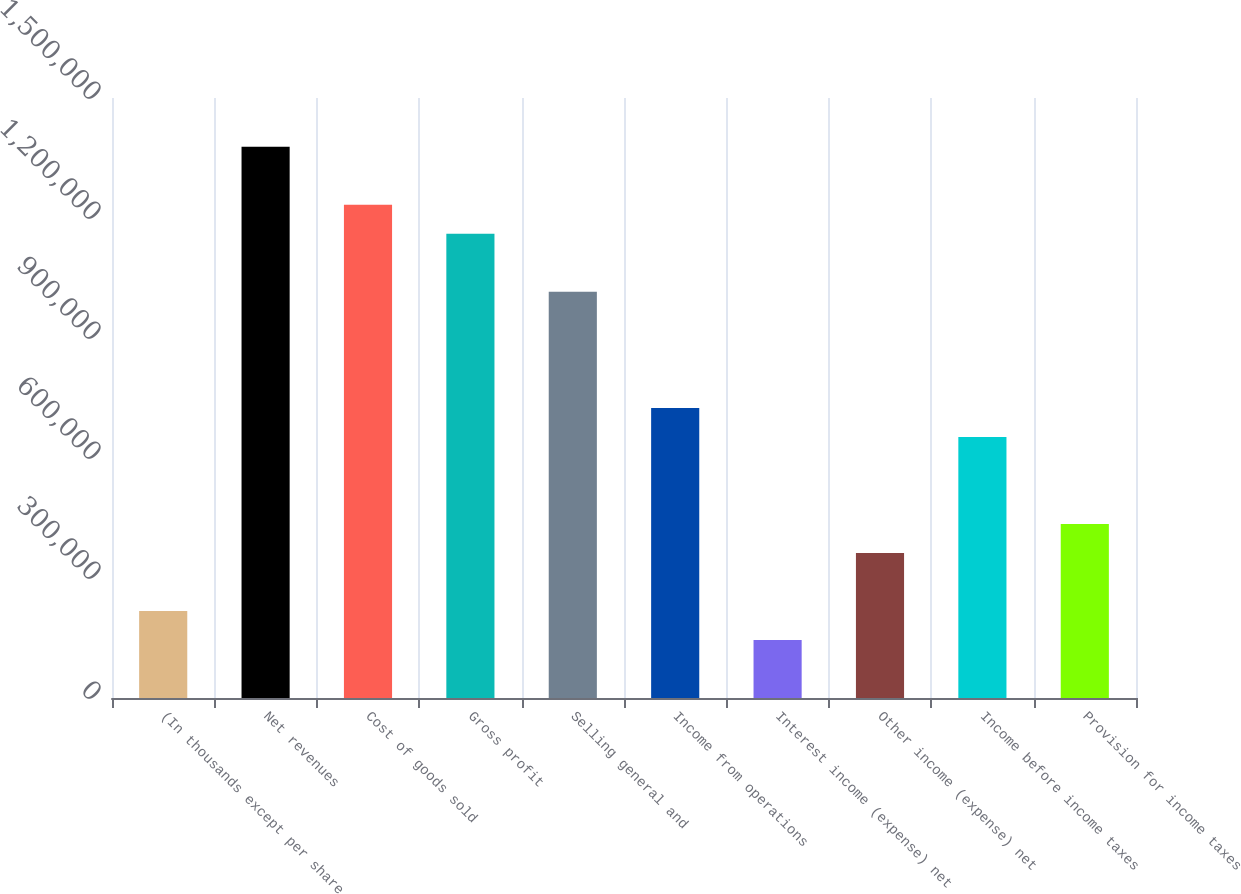Convert chart. <chart><loc_0><loc_0><loc_500><loc_500><bar_chart><fcel>(In thousands except per share<fcel>Net revenues<fcel>Cost of goods sold<fcel>Gross profit<fcel>Selling general and<fcel>Income from operations<fcel>Interest income (expense) net<fcel>Other income (expense) net<fcel>Income before income taxes<fcel>Provision for income taxes<nl><fcel>217574<fcel>1.37796e+06<fcel>1.23291e+06<fcel>1.16039e+06<fcel>1.01534e+06<fcel>725244<fcel>145049<fcel>362622<fcel>652720<fcel>435147<nl></chart> 